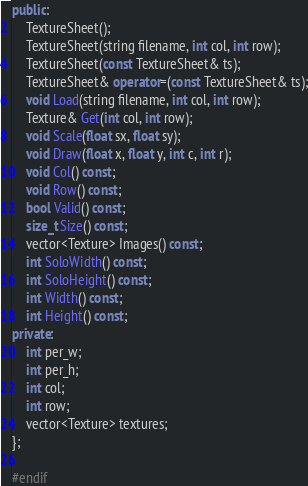Convert code to text. <code><loc_0><loc_0><loc_500><loc_500><_C++_>public:
    TextureSheet();
    TextureSheet(string filename, int col, int row);
    TextureSheet(const TextureSheet& ts);
    TextureSheet& operator=(const TextureSheet& ts);
    void Load(string filename, int col, int row);
    Texture& Get(int col, int row);
    void Scale(float sx, float sy);
    void Draw(float x, float y, int c, int r);
    void Col() const;
    void Row() const;
    bool Valid() const;
    size_t Size() const;
    vector<Texture> Images() const;
    int SoloWidth() const;
    int SoloHeight() const;
    int Width() const;
    int Height() const;
private:
    int per_w;
    int per_h;
    int col;
    int row;
    vector<Texture> textures;
};

#endif
</code> 